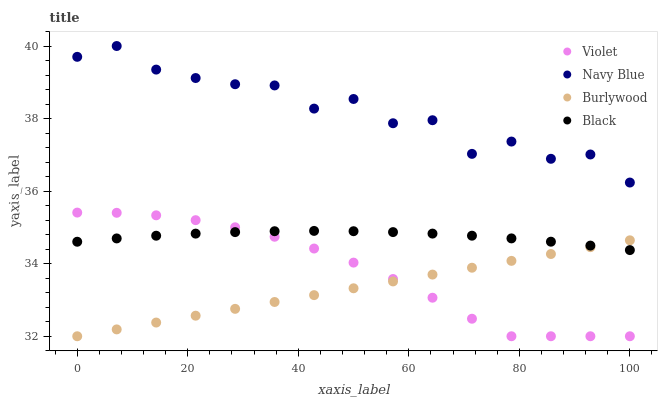Does Burlywood have the minimum area under the curve?
Answer yes or no. Yes. Does Navy Blue have the maximum area under the curve?
Answer yes or no. Yes. Does Black have the minimum area under the curve?
Answer yes or no. No. Does Black have the maximum area under the curve?
Answer yes or no. No. Is Burlywood the smoothest?
Answer yes or no. Yes. Is Navy Blue the roughest?
Answer yes or no. Yes. Is Black the smoothest?
Answer yes or no. No. Is Black the roughest?
Answer yes or no. No. Does Burlywood have the lowest value?
Answer yes or no. Yes. Does Black have the lowest value?
Answer yes or no. No. Does Navy Blue have the highest value?
Answer yes or no. Yes. Does Black have the highest value?
Answer yes or no. No. Is Black less than Navy Blue?
Answer yes or no. Yes. Is Navy Blue greater than Violet?
Answer yes or no. Yes. Does Black intersect Burlywood?
Answer yes or no. Yes. Is Black less than Burlywood?
Answer yes or no. No. Is Black greater than Burlywood?
Answer yes or no. No. Does Black intersect Navy Blue?
Answer yes or no. No. 